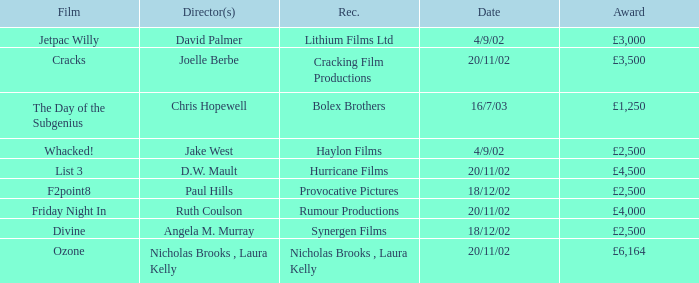Who directed a film for Cracking Film Productions? Joelle Berbe. 